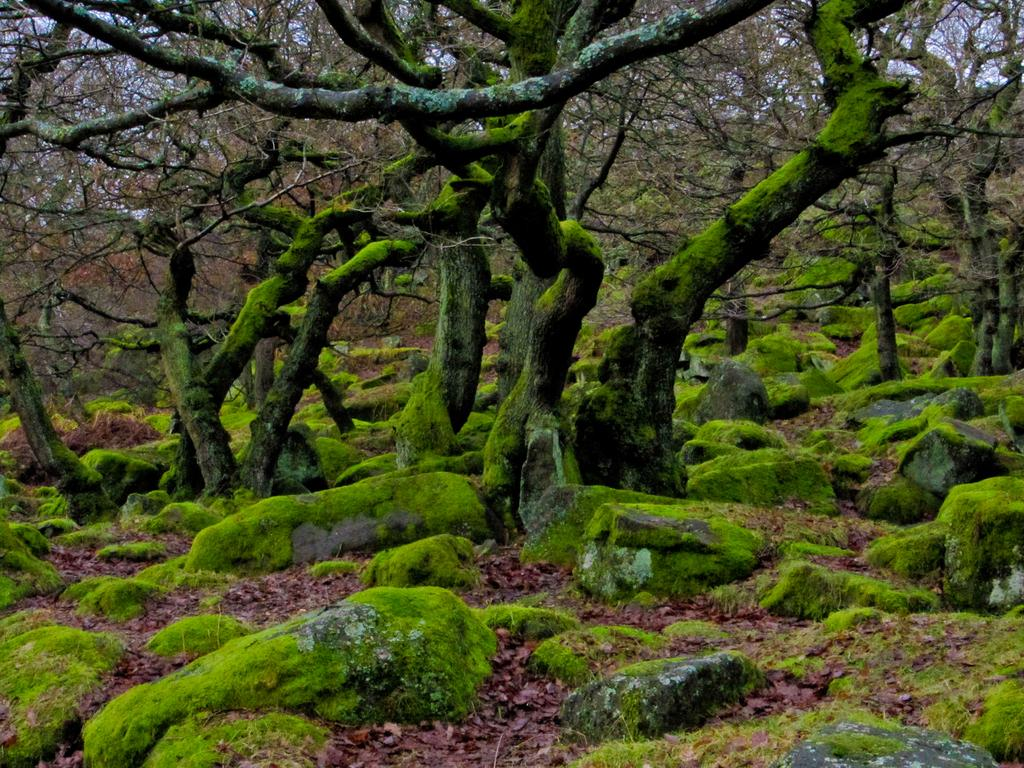What type of vegetation can be seen in the image? There are trees in the image. What can be found on the ground in the image? There are rocks on the ground in the image. What is covering the trees and rocks in the image? Moss is present on the trees and rocks in the image. What else can be seen on the ground in the image? Dry leaves are visible on the ground in the image. What type of pie is being served in the image? There is no pie present in the image; it features trees, rocks, moss, and dry leaves. 